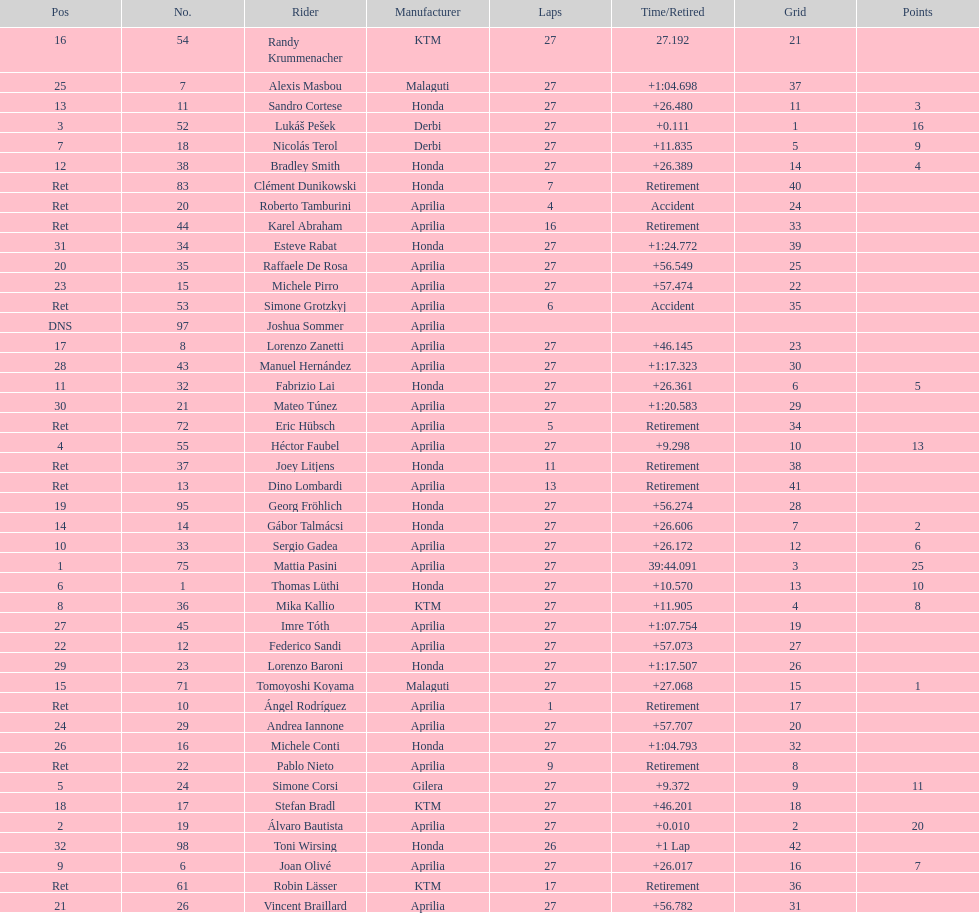Out of all the people who have points, who has the least? Tomoyoshi Koyama. 